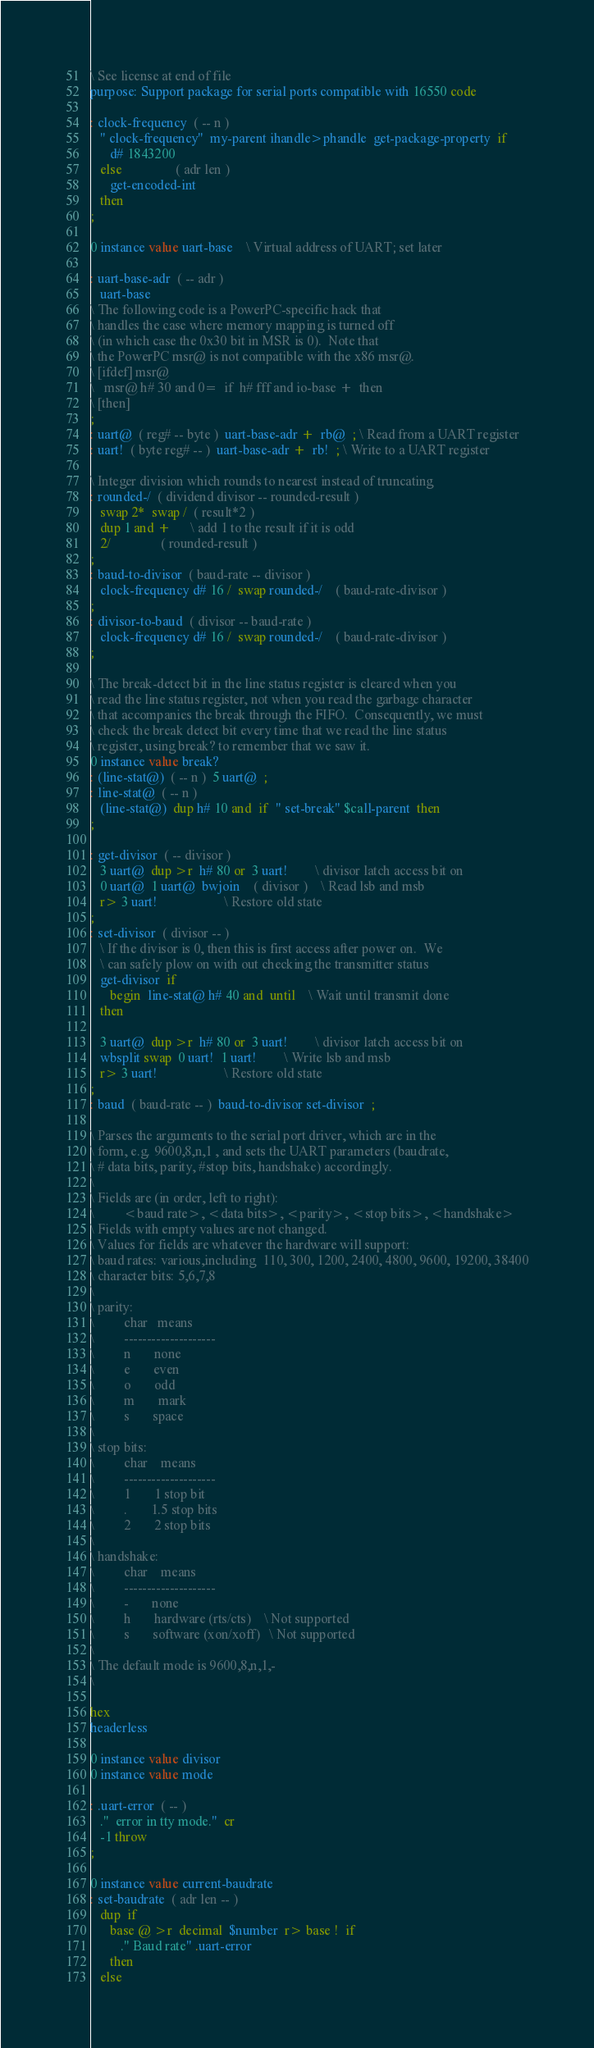Convert code to text. <code><loc_0><loc_0><loc_500><loc_500><_Forth_>\ See license at end of file
purpose: Support package for serial ports compatible with 16550 code

: clock-frequency  ( -- n )
   " clock-frequency"  my-parent ihandle>phandle  get-package-property  if
      d# 1843200
   else                ( adr len )
      get-encoded-int
   then
;

0 instance value uart-base	\ Virtual address of UART; set later

: uart-base-adr  ( -- adr )
   uart-base
\ The following code is a PowerPC-specific hack that 
\ handles the case where memory mapping is turned off
\ (in which case the 0x30 bit in MSR is 0).  Note that
\ the PowerPC msr@ is not compatible with the x86 msr@.
\ [ifdef] msr@
\   msr@ h# 30 and 0=  if  h# fff and io-base +  then
\ [then]
;
: uart@  ( reg# -- byte )  uart-base-adr +  rb@  ; \ Read from a UART register
: uart!  ( byte reg# -- )  uart-base-adr +  rb!  ; \ Write to a UART register

\ Integer division which rounds to nearest instead of truncating
: rounded-/  ( dividend divisor -- rounded-result )
   swap 2*  swap /  ( result*2 )
   dup 1 and +      \ add 1 to the result if it is odd
   2/               ( rounded-result )
;
: baud-to-divisor  ( baud-rate -- divisor )
   clock-frequency d# 16 /  swap rounded-/    ( baud-rate-divisor )
;
: divisor-to-baud  ( divisor -- baud-rate )
   clock-frequency d# 16 /  swap rounded-/    ( baud-rate-divisor )
;

\ The break-detect bit in the line status register is cleared when you
\ read the line status register, not when you read the garbage character
\ that accompanies the break through the FIFO.  Consequently, we must
\ check the break detect bit every time that we read the line status
\ register, using break? to remember that we saw it.
0 instance value break?
: (line-stat@)  ( -- n )  5 uart@  ;
: line-stat@  ( -- n )
   (line-stat@)  dup h# 10 and  if  " set-break" $call-parent  then
;

: get-divisor  ( -- divisor )
   3 uart@  dup >r  h# 80 or  3 uart!		\ divisor latch access bit on
   0 uart@  1 uart@  bwjoin	( divisor )	\ Read lsb and msb
   r> 3 uart!					\ Restore old state
;
: set-divisor  ( divisor -- )
   \ If the divisor is 0, then this is first access after power on.  We
   \ can safely plow on with out checking the transmitter status
   get-divisor  if
      begin  line-stat@ h# 40 and  until	\ Wait until transmit done
   then

   3 uart@  dup >r  h# 80 or  3 uart!		\ divisor latch access bit on
   wbsplit swap  0 uart!  1 uart!		\ Write lsb and msb
   r> 3 uart!					\ Restore old state
;
: baud  ( baud-rate -- )  baud-to-divisor set-divisor  ;

\ Parses the arguments to the serial port driver, which are in the
\ form, e.g. 9600,8,n,1 , and sets the UART parameters (baudrate,
\ # data bits, parity, #stop bits, handshake) accordingly.
\
\ Fields are (in order, left to right):
\         <baud rate>, <data bits>, <parity>, <stop bits>, <handshake>
\ Fields with empty values are not changed.
\ Values for fields are whatever the hardware will support:
\ baud rates: various,including  110, 300, 1200, 2400, 4800, 9600, 19200, 38400
\ character bits: 5,6,7,8
\
\ parity:
\         char   means
\         --------------------
\         n       none
\         e       even
\         o       odd
\         m       mark
\         s       space
\
\ stop bits:
\         char    means
\         --------------------
\         1       1 stop bit
\         .       1.5 stop bits
\         2       2 stop bits
\
\ handshake:
\         char    means
\         --------------------
\         -       none
\         h       hardware (rts/cts)	\ Not supported
\         s       software (xon/xoff)   \ Not supported
\
\ The default mode is 9600,8,n,1,-
\

hex
headerless

0 instance value divisor
0 instance value mode

: .uart-error  ( -- )
   ."  error in tty mode."  cr
   -1 throw
;

0 instance value current-baudrate
: set-baudrate  ( adr len -- )
   dup  if
      base @ >r  decimal  $number  r> base !  if
         ." Baud rate" .uart-error
      then
   else</code> 